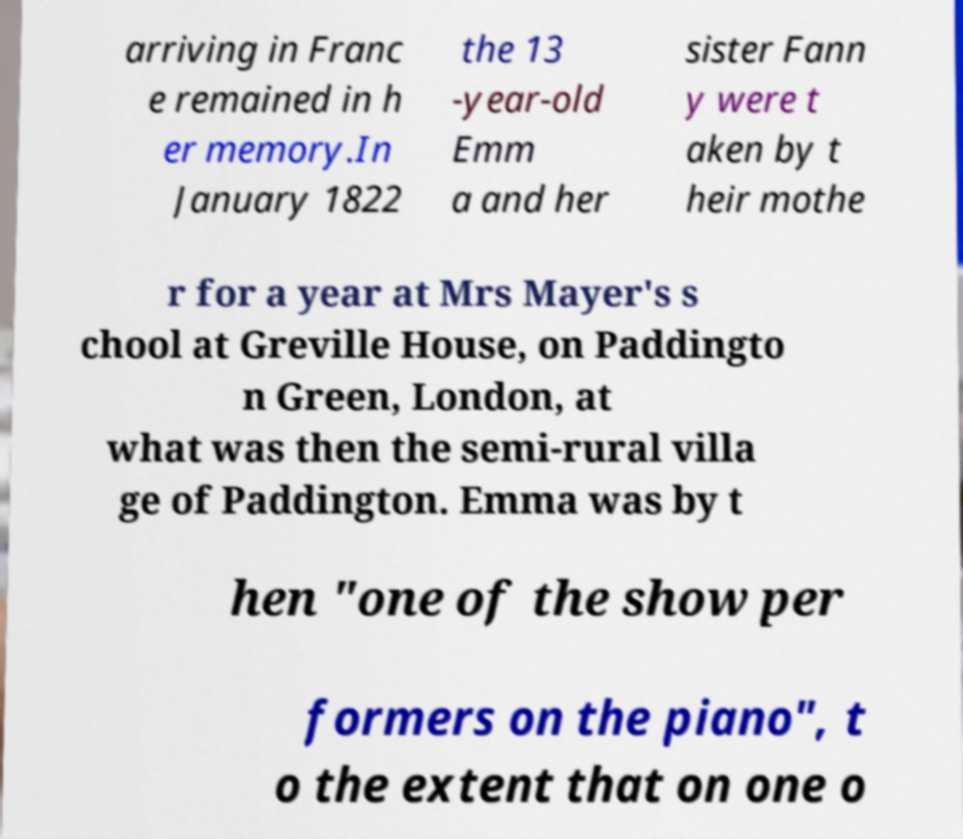For documentation purposes, I need the text within this image transcribed. Could you provide that? arriving in Franc e remained in h er memory.In January 1822 the 13 -year-old Emm a and her sister Fann y were t aken by t heir mothe r for a year at Mrs Mayer's s chool at Greville House, on Paddingto n Green, London, at what was then the semi-rural villa ge of Paddington. Emma was by t hen "one of the show per formers on the piano", t o the extent that on one o 